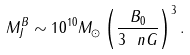Convert formula to latex. <formula><loc_0><loc_0><loc_500><loc_500>M _ { J } ^ { B } \sim 1 0 ^ { 1 0 } M _ { \odot } \left ( \frac { B _ { 0 } } { 3 \ n G } \right ) ^ { 3 } .</formula> 